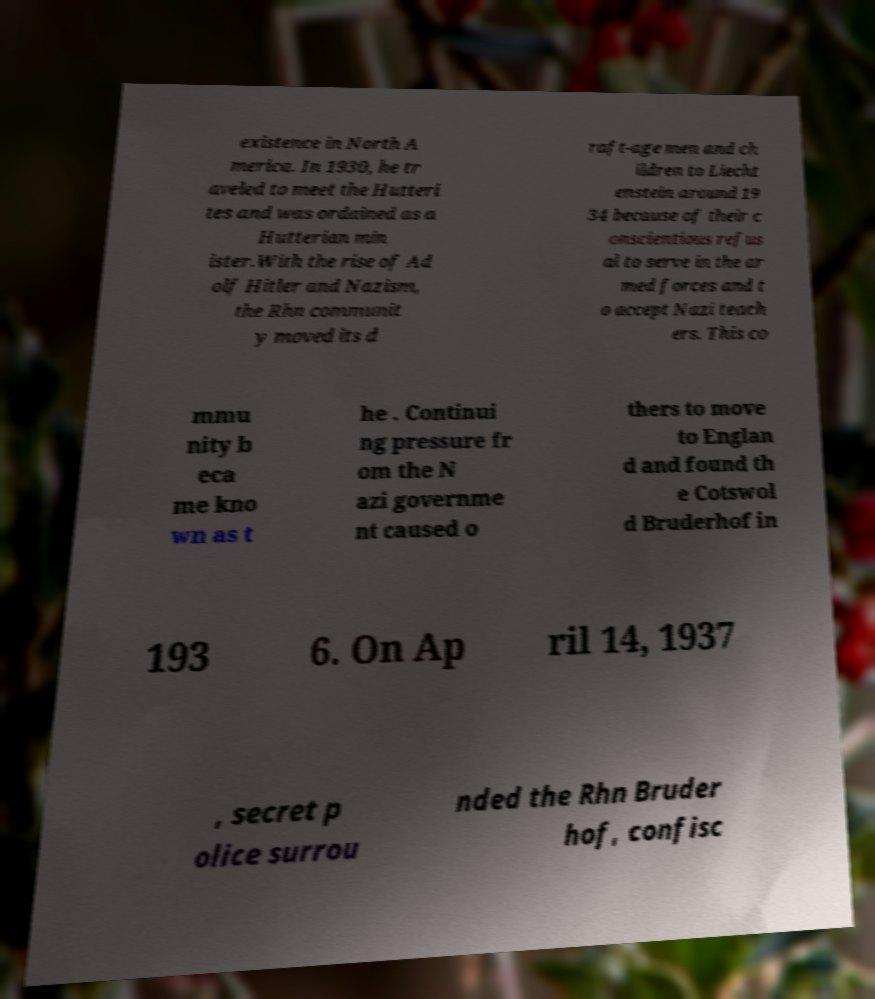What messages or text are displayed in this image? I need them in a readable, typed format. existence in North A merica. In 1930, he tr aveled to meet the Hutteri tes and was ordained as a Hutterian min ister.With the rise of Ad olf Hitler and Nazism, the Rhn communit y moved its d raft-age men and ch ildren to Liecht enstein around 19 34 because of their c onscientious refus al to serve in the ar med forces and t o accept Nazi teach ers. This co mmu nity b eca me kno wn as t he . Continui ng pressure fr om the N azi governme nt caused o thers to move to Englan d and found th e Cotswol d Bruderhof in 193 6. On Ap ril 14, 1937 , secret p olice surrou nded the Rhn Bruder hof, confisc 